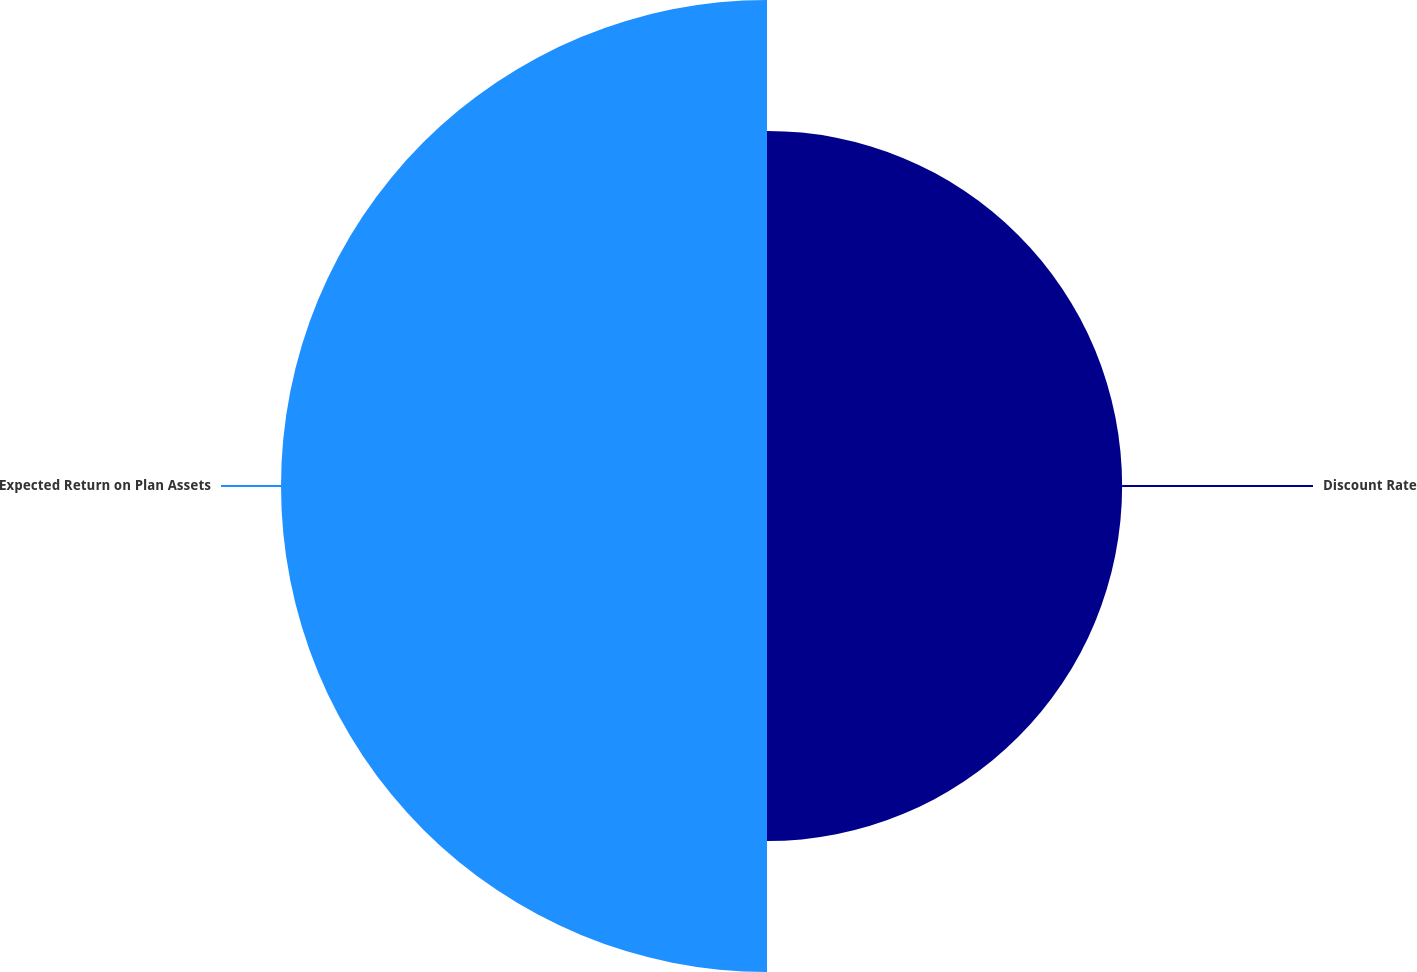Convert chart to OTSL. <chart><loc_0><loc_0><loc_500><loc_500><pie_chart><fcel>Discount Rate<fcel>Expected Return on Plan Assets<nl><fcel>42.22%<fcel>57.78%<nl></chart> 